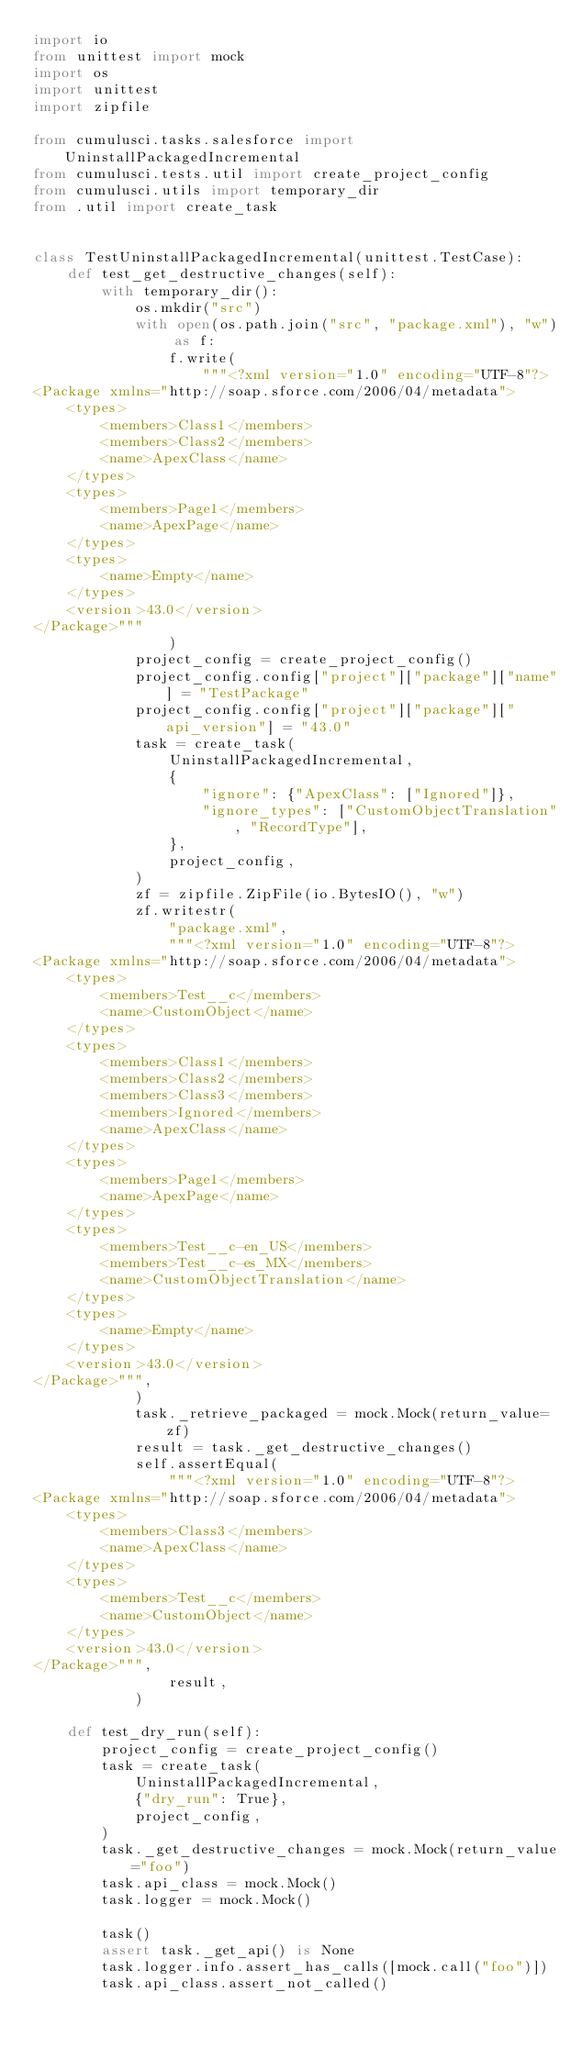<code> <loc_0><loc_0><loc_500><loc_500><_Python_>import io
from unittest import mock
import os
import unittest
import zipfile

from cumulusci.tasks.salesforce import UninstallPackagedIncremental
from cumulusci.tests.util import create_project_config
from cumulusci.utils import temporary_dir
from .util import create_task


class TestUninstallPackagedIncremental(unittest.TestCase):
    def test_get_destructive_changes(self):
        with temporary_dir():
            os.mkdir("src")
            with open(os.path.join("src", "package.xml"), "w") as f:
                f.write(
                    """<?xml version="1.0" encoding="UTF-8"?>
<Package xmlns="http://soap.sforce.com/2006/04/metadata">
    <types>
        <members>Class1</members>
        <members>Class2</members>
        <name>ApexClass</name>
    </types>
    <types>
        <members>Page1</members>
        <name>ApexPage</name>
    </types>
    <types>
        <name>Empty</name>
    </types>
    <version>43.0</version>
</Package>"""
                )
            project_config = create_project_config()
            project_config.config["project"]["package"]["name"] = "TestPackage"
            project_config.config["project"]["package"]["api_version"] = "43.0"
            task = create_task(
                UninstallPackagedIncremental,
                {
                    "ignore": {"ApexClass": ["Ignored"]},
                    "ignore_types": ["CustomObjectTranslation", "RecordType"],
                },
                project_config,
            )
            zf = zipfile.ZipFile(io.BytesIO(), "w")
            zf.writestr(
                "package.xml",
                """<?xml version="1.0" encoding="UTF-8"?>
<Package xmlns="http://soap.sforce.com/2006/04/metadata">
    <types>
        <members>Test__c</members>
        <name>CustomObject</name>
    </types>
    <types>
        <members>Class1</members>
        <members>Class2</members>
        <members>Class3</members>
        <members>Ignored</members>
        <name>ApexClass</name>
    </types>
    <types>
        <members>Page1</members>
        <name>ApexPage</name>
    </types>
    <types>
        <members>Test__c-en_US</members>
        <members>Test__c-es_MX</members>
        <name>CustomObjectTranslation</name>
    </types>
    <types>
        <name>Empty</name>
    </types>
    <version>43.0</version>
</Package>""",
            )
            task._retrieve_packaged = mock.Mock(return_value=zf)
            result = task._get_destructive_changes()
            self.assertEqual(
                """<?xml version="1.0" encoding="UTF-8"?>
<Package xmlns="http://soap.sforce.com/2006/04/metadata">
    <types>
        <members>Class3</members>
        <name>ApexClass</name>
    </types>
    <types>
        <members>Test__c</members>
        <name>CustomObject</name>
    </types>
    <version>43.0</version>
</Package>""",
                result,
            )

    def test_dry_run(self):
        project_config = create_project_config()
        task = create_task(
            UninstallPackagedIncremental,
            {"dry_run": True},
            project_config,
        )
        task._get_destructive_changes = mock.Mock(return_value="foo")
        task.api_class = mock.Mock()
        task.logger = mock.Mock()

        task()
        assert task._get_api() is None
        task.logger.info.assert_has_calls([mock.call("foo")])
        task.api_class.assert_not_called()
</code> 